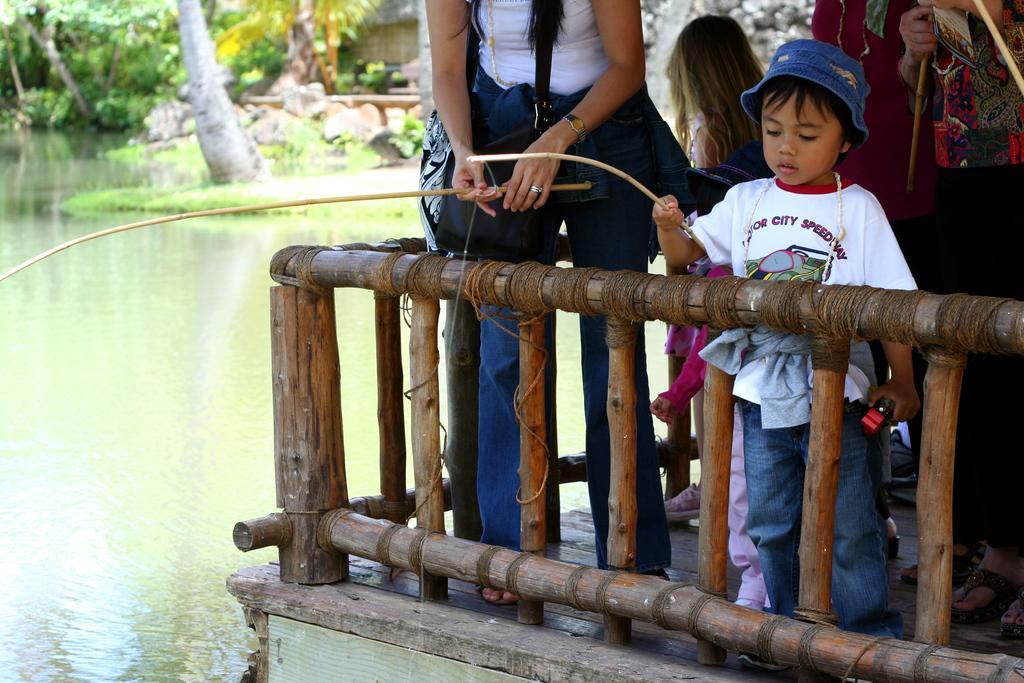Could you give a brief overview of what you see in this image? In this image we can see a group of people standing on the floor holding sticks in their hands. One boy is wearing a cap is holding an object in his hand and stick with the other hand. In the foreground we can see a fence. In the background, we can see the water and a group of trees and some rocks. 